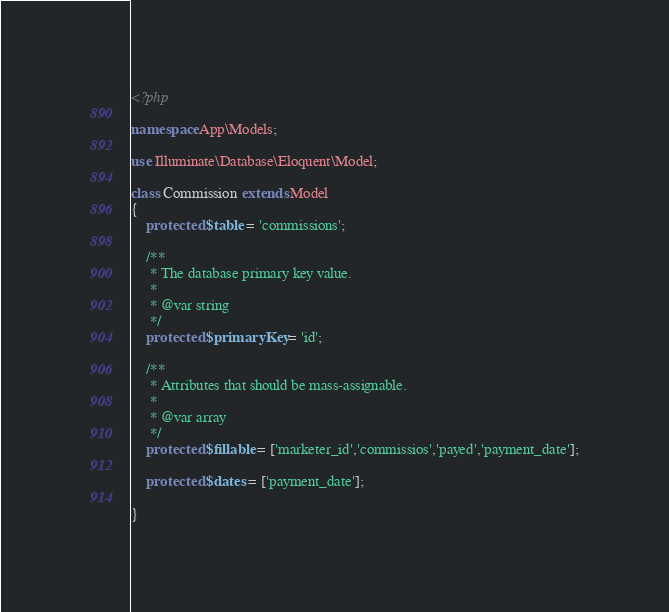<code> <loc_0><loc_0><loc_500><loc_500><_PHP_><?php

namespace App\Models;

use Illuminate\Database\Eloquent\Model;

class Commission extends Model
{
    protected $table = 'commissions';

    /**
     * The database primary key value.
     *
     * @var string
     */
    protected $primaryKey = 'id';

    /**
     * Attributes that should be mass-assignable.
     *
     * @var array
     */
    protected $fillable = ['marketer_id','commissios','payed','payment_date'];

    protected $dates = ['payment_date'];

}
</code> 